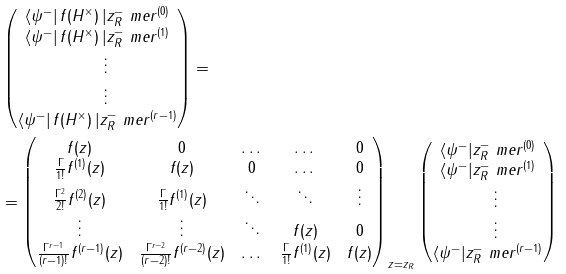<formula> <loc_0><loc_0><loc_500><loc_500>& \begin{pmatrix} \langle \psi ^ { - } | \, f ( H ^ { \times } ) \, | z ^ { - } _ { R } \ m e r ^ { ( 0 ) } \\ \langle \psi ^ { - } | \, f ( H ^ { \times } ) \, | z ^ { - } _ { R } \ m e r ^ { ( 1 ) } \\ \quad \vdots \\ \quad \vdots \\ \langle \psi ^ { - } | \, f ( H ^ { \times } ) \, | z ^ { - } _ { R } \ m e r ^ { ( r - 1 ) } \\ \end{pmatrix} = \\ & = \begin{pmatrix} f ( z ) & 0 & \dots & \dots & 0 \\ \frac { \Gamma } { 1 ! } f ^ { ( 1 ) } ( z ) & f ( z ) & 0 & \dots & 0 \\ \frac { \Gamma ^ { 2 } } { 2 ! } f ^ { ( 2 ) } ( z ) & \frac { \Gamma } { 1 ! } f ^ { ( 1 ) } ( z ) & \ddots & \ddots & \vdots \\ \vdots & \vdots & \ddots & f ( z ) & 0 \\ \frac { \Gamma ^ { r - 1 } } { ( r - 1 ) ! } f ^ { ( r - 1 ) } ( z ) & \frac { \Gamma ^ { r - 2 } } { ( r - 2 ) ! } f ^ { ( r - 2 ) } ( z ) & \dots & \frac { \Gamma } { 1 ! } f ^ { ( 1 ) } ( z ) & f ( z ) \end{pmatrix} _ { \, z = z _ { R } } \begin{pmatrix} \langle \psi ^ { - } | z ^ { - } _ { R } \ m e r ^ { ( 0 ) } \\ \langle \psi ^ { - } | z ^ { - } _ { R } \ m e r ^ { ( 1 ) } \\ \quad \vdots \\ \quad \vdots \\ \langle \psi ^ { - } | z ^ { - } _ { R } \ m e r ^ { ( r - 1 ) } \\ \end{pmatrix}</formula> 